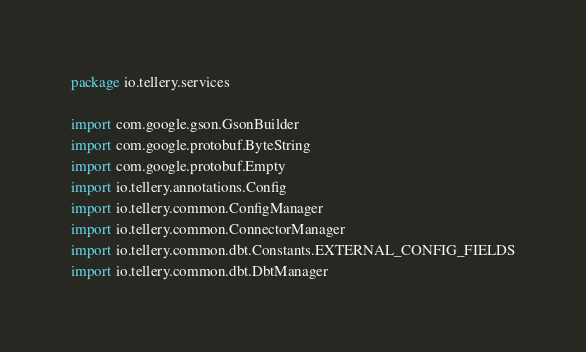Convert code to text. <code><loc_0><loc_0><loc_500><loc_500><_Kotlin_>package io.tellery.services

import com.google.gson.GsonBuilder
import com.google.protobuf.ByteString
import com.google.protobuf.Empty
import io.tellery.annotations.Config
import io.tellery.common.ConfigManager
import io.tellery.common.ConnectorManager
import io.tellery.common.dbt.Constants.EXTERNAL_CONFIG_FIELDS
import io.tellery.common.dbt.DbtManager</code> 